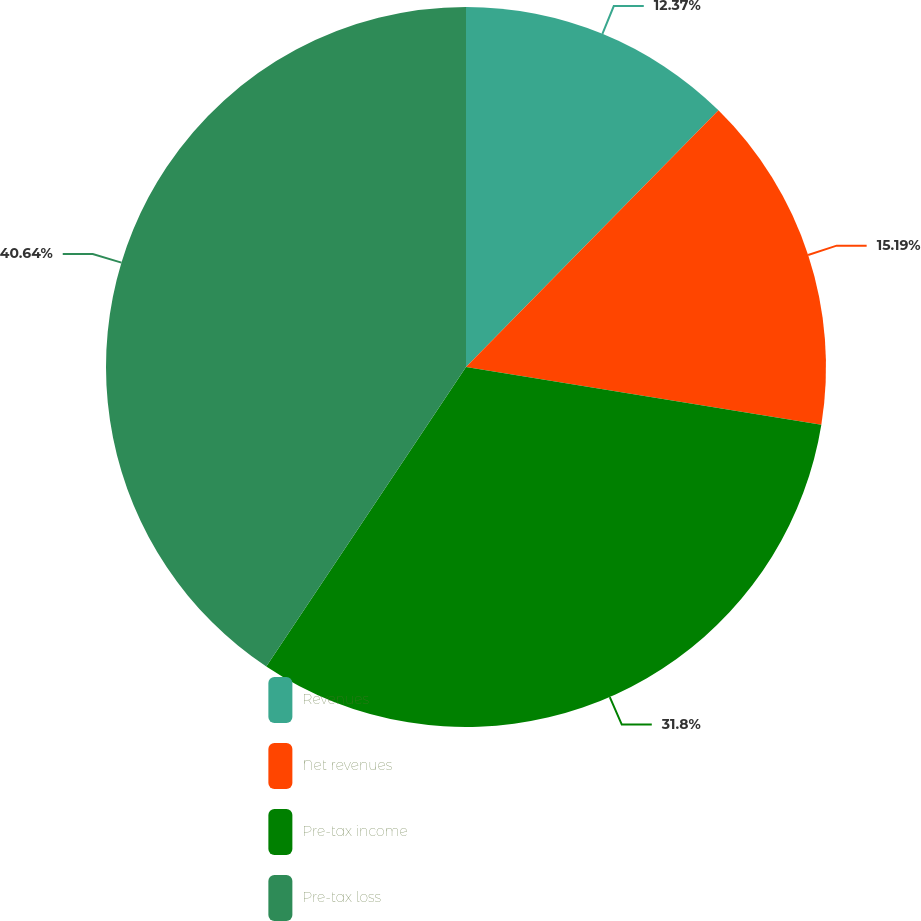Convert chart to OTSL. <chart><loc_0><loc_0><loc_500><loc_500><pie_chart><fcel>Revenues<fcel>Net revenues<fcel>Pre-tax income<fcel>Pre-tax loss<nl><fcel>12.37%<fcel>15.19%<fcel>31.8%<fcel>40.64%<nl></chart> 